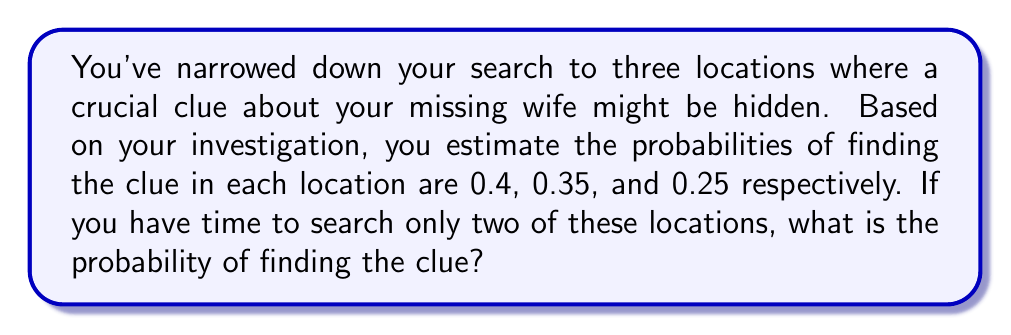Show me your answer to this math problem. Let's approach this step-by-step:

1) First, let's define our events:
   A: Finding the clue in the first location (P(A) = 0.4)
   B: Finding the clue in the second location (P(B) = 0.35)
   C: Finding the clue in the third location (P(C) = 0.25)

2) We want to find the probability of finding the clue if we search two locations. This is equivalent to finding the probability of success in at least one of the two searches.

3) To calculate this, it's easier to find the probability of not finding the clue in either location and then subtract this from 1.

4) If we choose to search locations A and B:
   P(not finding in A or B) = P(not A) × P(not B)
   = (1 - 0.4) × (1 - 0.35)
   = 0.6 × 0.65
   = 0.39

5) Therefore, the probability of finding the clue in either A or B is:
   P(finding in A or B) = 1 - P(not finding in A or B)
   = 1 - 0.39
   = 0.61

6) We can repeat this calculation for the other possible pairs:
   For A and C: 1 - (0.6 × 0.75) = 0.55
   For B and C: 1 - (0.65 × 0.75) = 0.5125

7) The best strategy is to choose the pair with the highest probability, which is A and B.

Therefore, the probability of finding the clue if you search two locations is 0.61 or 61%.
Answer: 0.61 